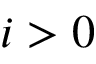<formula> <loc_0><loc_0><loc_500><loc_500>i > 0</formula> 